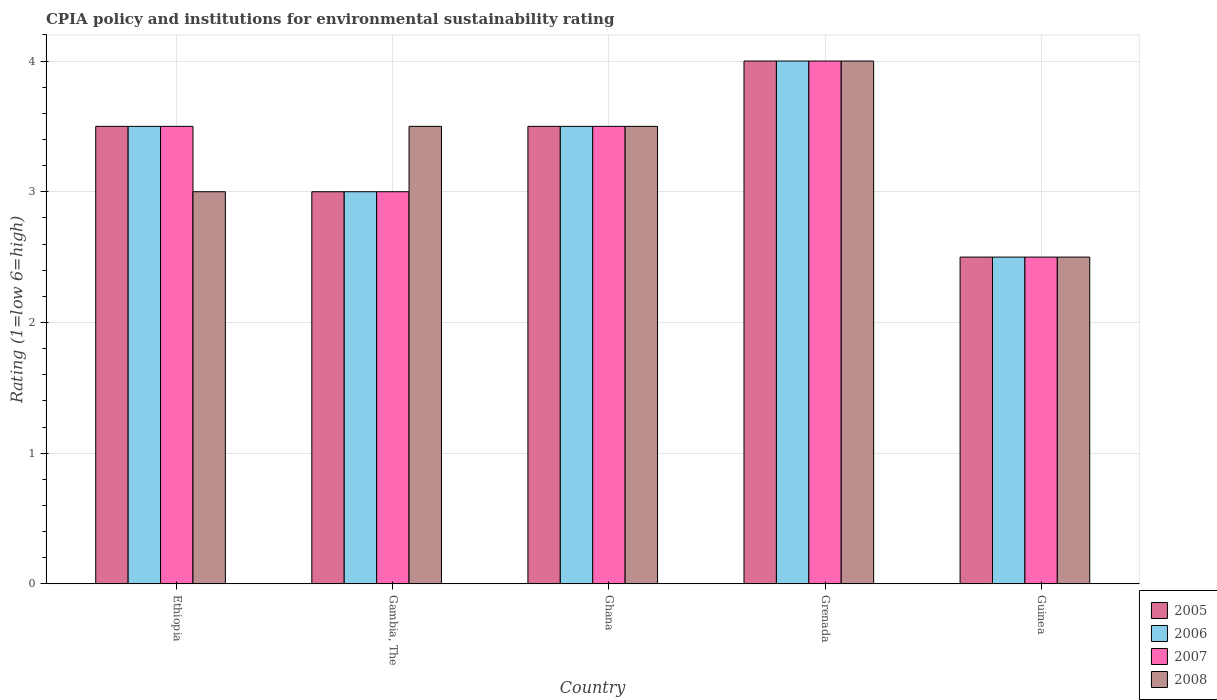How many groups of bars are there?
Ensure brevity in your answer.  5. What is the label of the 1st group of bars from the left?
Offer a terse response. Ethiopia. In how many cases, is the number of bars for a given country not equal to the number of legend labels?
Your answer should be compact. 0. What is the CPIA rating in 2007 in Guinea?
Provide a succinct answer. 2.5. Across all countries, what is the maximum CPIA rating in 2007?
Offer a terse response. 4. Across all countries, what is the minimum CPIA rating in 2006?
Offer a very short reply. 2.5. In which country was the CPIA rating in 2006 maximum?
Ensure brevity in your answer.  Grenada. In which country was the CPIA rating in 2006 minimum?
Provide a succinct answer. Guinea. What is the difference between the CPIA rating in 2008 in Ghana and that in Guinea?
Keep it short and to the point. 1. What is the average CPIA rating in 2005 per country?
Keep it short and to the point. 3.3. What is the difference between the CPIA rating of/in 2008 and CPIA rating of/in 2005 in Ghana?
Provide a succinct answer. 0. In how many countries, is the CPIA rating in 2005 greater than 1.6?
Offer a terse response. 5. Is the CPIA rating in 2007 in Ethiopia less than that in Grenada?
Provide a short and direct response. Yes. Is the sum of the CPIA rating in 2006 in Gambia, The and Guinea greater than the maximum CPIA rating in 2007 across all countries?
Offer a terse response. Yes. Is it the case that in every country, the sum of the CPIA rating in 2007 and CPIA rating in 2005 is greater than the sum of CPIA rating in 2008 and CPIA rating in 2006?
Offer a terse response. No. Are all the bars in the graph horizontal?
Your response must be concise. No. Does the graph contain any zero values?
Provide a succinct answer. No. Does the graph contain grids?
Offer a terse response. Yes. How many legend labels are there?
Ensure brevity in your answer.  4. What is the title of the graph?
Your answer should be compact. CPIA policy and institutions for environmental sustainability rating. Does "2005" appear as one of the legend labels in the graph?
Provide a short and direct response. Yes. What is the label or title of the X-axis?
Make the answer very short. Country. What is the Rating (1=low 6=high) of 2006 in Ethiopia?
Your answer should be compact. 3.5. What is the Rating (1=low 6=high) of 2005 in Gambia, The?
Offer a very short reply. 3. What is the Rating (1=low 6=high) of 2007 in Gambia, The?
Offer a very short reply. 3. What is the Rating (1=low 6=high) in 2005 in Guinea?
Provide a short and direct response. 2.5. What is the Rating (1=low 6=high) in 2006 in Guinea?
Give a very brief answer. 2.5. What is the Rating (1=low 6=high) of 2007 in Guinea?
Ensure brevity in your answer.  2.5. Across all countries, what is the maximum Rating (1=low 6=high) in 2005?
Ensure brevity in your answer.  4. Across all countries, what is the minimum Rating (1=low 6=high) in 2005?
Provide a short and direct response. 2.5. Across all countries, what is the minimum Rating (1=low 6=high) in 2007?
Provide a short and direct response. 2.5. Across all countries, what is the minimum Rating (1=low 6=high) of 2008?
Your answer should be compact. 2.5. What is the total Rating (1=low 6=high) in 2007 in the graph?
Offer a very short reply. 16.5. What is the total Rating (1=low 6=high) in 2008 in the graph?
Your answer should be compact. 16.5. What is the difference between the Rating (1=low 6=high) of 2005 in Ethiopia and that in Gambia, The?
Ensure brevity in your answer.  0.5. What is the difference between the Rating (1=low 6=high) of 2007 in Ethiopia and that in Gambia, The?
Provide a short and direct response. 0.5. What is the difference between the Rating (1=low 6=high) of 2008 in Ethiopia and that in Gambia, The?
Offer a very short reply. -0.5. What is the difference between the Rating (1=low 6=high) of 2007 in Ethiopia and that in Ghana?
Provide a succinct answer. 0. What is the difference between the Rating (1=low 6=high) in 2005 in Ethiopia and that in Grenada?
Your answer should be very brief. -0.5. What is the difference between the Rating (1=low 6=high) of 2006 in Ethiopia and that in Grenada?
Your answer should be very brief. -0.5. What is the difference between the Rating (1=low 6=high) of 2007 in Ethiopia and that in Grenada?
Offer a very short reply. -0.5. What is the difference between the Rating (1=low 6=high) of 2008 in Ethiopia and that in Grenada?
Your answer should be very brief. -1. What is the difference between the Rating (1=low 6=high) in 2005 in Ethiopia and that in Guinea?
Provide a succinct answer. 1. What is the difference between the Rating (1=low 6=high) of 2006 in Ethiopia and that in Guinea?
Make the answer very short. 1. What is the difference between the Rating (1=low 6=high) of 2007 in Ethiopia and that in Guinea?
Offer a very short reply. 1. What is the difference between the Rating (1=low 6=high) in 2005 in Gambia, The and that in Ghana?
Your answer should be compact. -0.5. What is the difference between the Rating (1=low 6=high) in 2007 in Gambia, The and that in Ghana?
Make the answer very short. -0.5. What is the difference between the Rating (1=low 6=high) in 2006 in Gambia, The and that in Grenada?
Offer a terse response. -1. What is the difference between the Rating (1=low 6=high) of 2008 in Gambia, The and that in Grenada?
Provide a succinct answer. -0.5. What is the difference between the Rating (1=low 6=high) in 2005 in Gambia, The and that in Guinea?
Provide a succinct answer. 0.5. What is the difference between the Rating (1=low 6=high) of 2008 in Gambia, The and that in Guinea?
Your response must be concise. 1. What is the difference between the Rating (1=low 6=high) of 2005 in Ghana and that in Grenada?
Make the answer very short. -0.5. What is the difference between the Rating (1=low 6=high) of 2006 in Grenada and that in Guinea?
Offer a terse response. 1.5. What is the difference between the Rating (1=low 6=high) of 2008 in Grenada and that in Guinea?
Your answer should be compact. 1.5. What is the difference between the Rating (1=low 6=high) in 2005 in Ethiopia and the Rating (1=low 6=high) in 2007 in Gambia, The?
Provide a short and direct response. 0.5. What is the difference between the Rating (1=low 6=high) in 2005 in Ethiopia and the Rating (1=low 6=high) in 2008 in Gambia, The?
Offer a very short reply. 0. What is the difference between the Rating (1=low 6=high) in 2006 in Ethiopia and the Rating (1=low 6=high) in 2008 in Gambia, The?
Make the answer very short. 0. What is the difference between the Rating (1=low 6=high) of 2007 in Ethiopia and the Rating (1=low 6=high) of 2008 in Gambia, The?
Offer a very short reply. 0. What is the difference between the Rating (1=low 6=high) in 2005 in Ethiopia and the Rating (1=low 6=high) in 2006 in Ghana?
Make the answer very short. 0. What is the difference between the Rating (1=low 6=high) of 2006 in Ethiopia and the Rating (1=low 6=high) of 2007 in Ghana?
Your response must be concise. 0. What is the difference between the Rating (1=low 6=high) in 2007 in Ethiopia and the Rating (1=low 6=high) in 2008 in Ghana?
Keep it short and to the point. 0. What is the difference between the Rating (1=low 6=high) in 2005 in Ethiopia and the Rating (1=low 6=high) in 2006 in Grenada?
Ensure brevity in your answer.  -0.5. What is the difference between the Rating (1=low 6=high) of 2005 in Ethiopia and the Rating (1=low 6=high) of 2008 in Grenada?
Ensure brevity in your answer.  -0.5. What is the difference between the Rating (1=low 6=high) of 2006 in Ethiopia and the Rating (1=low 6=high) of 2007 in Grenada?
Your answer should be compact. -0.5. What is the difference between the Rating (1=low 6=high) of 2006 in Ethiopia and the Rating (1=low 6=high) of 2008 in Grenada?
Make the answer very short. -0.5. What is the difference between the Rating (1=low 6=high) of 2007 in Ethiopia and the Rating (1=low 6=high) of 2008 in Grenada?
Keep it short and to the point. -0.5. What is the difference between the Rating (1=low 6=high) of 2005 in Ethiopia and the Rating (1=low 6=high) of 2007 in Guinea?
Offer a very short reply. 1. What is the difference between the Rating (1=low 6=high) of 2006 in Ethiopia and the Rating (1=low 6=high) of 2007 in Guinea?
Your response must be concise. 1. What is the difference between the Rating (1=low 6=high) of 2006 in Ethiopia and the Rating (1=low 6=high) of 2008 in Guinea?
Make the answer very short. 1. What is the difference between the Rating (1=low 6=high) in 2007 in Ethiopia and the Rating (1=low 6=high) in 2008 in Guinea?
Your answer should be very brief. 1. What is the difference between the Rating (1=low 6=high) in 2005 in Gambia, The and the Rating (1=low 6=high) in 2006 in Ghana?
Offer a terse response. -0.5. What is the difference between the Rating (1=low 6=high) of 2005 in Gambia, The and the Rating (1=low 6=high) of 2007 in Ghana?
Keep it short and to the point. -0.5. What is the difference between the Rating (1=low 6=high) of 2006 in Gambia, The and the Rating (1=low 6=high) of 2007 in Ghana?
Provide a succinct answer. -0.5. What is the difference between the Rating (1=low 6=high) of 2006 in Gambia, The and the Rating (1=low 6=high) of 2008 in Ghana?
Offer a terse response. -0.5. What is the difference between the Rating (1=low 6=high) of 2007 in Gambia, The and the Rating (1=low 6=high) of 2008 in Ghana?
Keep it short and to the point. -0.5. What is the difference between the Rating (1=low 6=high) in 2005 in Gambia, The and the Rating (1=low 6=high) in 2008 in Grenada?
Your answer should be compact. -1. What is the difference between the Rating (1=low 6=high) in 2006 in Gambia, The and the Rating (1=low 6=high) in 2007 in Grenada?
Your answer should be very brief. -1. What is the difference between the Rating (1=low 6=high) in 2007 in Gambia, The and the Rating (1=low 6=high) in 2008 in Grenada?
Your answer should be compact. -1. What is the difference between the Rating (1=low 6=high) in 2005 in Gambia, The and the Rating (1=low 6=high) in 2006 in Guinea?
Ensure brevity in your answer.  0.5. What is the difference between the Rating (1=low 6=high) of 2005 in Gambia, The and the Rating (1=low 6=high) of 2007 in Guinea?
Make the answer very short. 0.5. What is the difference between the Rating (1=low 6=high) in 2005 in Gambia, The and the Rating (1=low 6=high) in 2008 in Guinea?
Your response must be concise. 0.5. What is the difference between the Rating (1=low 6=high) in 2005 in Ghana and the Rating (1=low 6=high) in 2006 in Grenada?
Give a very brief answer. -0.5. What is the difference between the Rating (1=low 6=high) of 2005 in Ghana and the Rating (1=low 6=high) of 2008 in Grenada?
Your answer should be very brief. -0.5. What is the difference between the Rating (1=low 6=high) in 2006 in Ghana and the Rating (1=low 6=high) in 2007 in Grenada?
Keep it short and to the point. -0.5. What is the difference between the Rating (1=low 6=high) of 2007 in Ghana and the Rating (1=low 6=high) of 2008 in Grenada?
Keep it short and to the point. -0.5. What is the difference between the Rating (1=low 6=high) in 2005 in Ghana and the Rating (1=low 6=high) in 2006 in Guinea?
Your response must be concise. 1. What is the difference between the Rating (1=low 6=high) of 2005 in Ghana and the Rating (1=low 6=high) of 2007 in Guinea?
Your answer should be very brief. 1. What is the difference between the Rating (1=low 6=high) in 2006 in Ghana and the Rating (1=low 6=high) in 2007 in Guinea?
Keep it short and to the point. 1. What is the difference between the Rating (1=low 6=high) of 2007 in Ghana and the Rating (1=low 6=high) of 2008 in Guinea?
Offer a very short reply. 1. What is the difference between the Rating (1=low 6=high) in 2005 in Grenada and the Rating (1=low 6=high) in 2007 in Guinea?
Your answer should be very brief. 1.5. What is the difference between the Rating (1=low 6=high) of 2006 in Grenada and the Rating (1=low 6=high) of 2008 in Guinea?
Offer a very short reply. 1.5. What is the average Rating (1=low 6=high) in 2005 per country?
Your answer should be very brief. 3.3. What is the average Rating (1=low 6=high) of 2006 per country?
Your answer should be compact. 3.3. What is the average Rating (1=low 6=high) in 2008 per country?
Provide a short and direct response. 3.3. What is the difference between the Rating (1=low 6=high) of 2005 and Rating (1=low 6=high) of 2006 in Ethiopia?
Keep it short and to the point. 0. What is the difference between the Rating (1=low 6=high) in 2005 and Rating (1=low 6=high) in 2008 in Ethiopia?
Provide a succinct answer. 0.5. What is the difference between the Rating (1=low 6=high) in 2006 and Rating (1=low 6=high) in 2007 in Ethiopia?
Offer a terse response. 0. What is the difference between the Rating (1=low 6=high) of 2007 and Rating (1=low 6=high) of 2008 in Ethiopia?
Your answer should be very brief. 0.5. What is the difference between the Rating (1=low 6=high) in 2005 and Rating (1=low 6=high) in 2007 in Gambia, The?
Provide a succinct answer. 0. What is the difference between the Rating (1=low 6=high) in 2006 and Rating (1=low 6=high) in 2007 in Gambia, The?
Ensure brevity in your answer.  0. What is the difference between the Rating (1=low 6=high) of 2006 and Rating (1=low 6=high) of 2008 in Gambia, The?
Your response must be concise. -0.5. What is the difference between the Rating (1=low 6=high) of 2007 and Rating (1=low 6=high) of 2008 in Gambia, The?
Keep it short and to the point. -0.5. What is the difference between the Rating (1=low 6=high) in 2005 and Rating (1=low 6=high) in 2006 in Ghana?
Your answer should be compact. 0. What is the difference between the Rating (1=low 6=high) in 2005 and Rating (1=low 6=high) in 2008 in Ghana?
Offer a terse response. 0. What is the difference between the Rating (1=low 6=high) in 2006 and Rating (1=low 6=high) in 2007 in Ghana?
Make the answer very short. 0. What is the difference between the Rating (1=low 6=high) in 2007 and Rating (1=low 6=high) in 2008 in Ghana?
Your answer should be compact. 0. What is the difference between the Rating (1=low 6=high) of 2005 and Rating (1=low 6=high) of 2006 in Grenada?
Provide a succinct answer. 0. What is the difference between the Rating (1=low 6=high) of 2005 and Rating (1=low 6=high) of 2007 in Grenada?
Your answer should be compact. 0. What is the difference between the Rating (1=low 6=high) in 2005 and Rating (1=low 6=high) in 2008 in Grenada?
Make the answer very short. 0. What is the difference between the Rating (1=low 6=high) of 2006 and Rating (1=low 6=high) of 2007 in Grenada?
Offer a very short reply. 0. What is the difference between the Rating (1=low 6=high) in 2007 and Rating (1=low 6=high) in 2008 in Grenada?
Your answer should be very brief. 0. What is the difference between the Rating (1=low 6=high) in 2005 and Rating (1=low 6=high) in 2007 in Guinea?
Keep it short and to the point. 0. What is the difference between the Rating (1=low 6=high) of 2006 and Rating (1=low 6=high) of 2007 in Guinea?
Offer a very short reply. 0. What is the difference between the Rating (1=low 6=high) of 2007 and Rating (1=low 6=high) of 2008 in Guinea?
Give a very brief answer. 0. What is the ratio of the Rating (1=low 6=high) of 2006 in Ethiopia to that in Gambia, The?
Keep it short and to the point. 1.17. What is the ratio of the Rating (1=low 6=high) in 2008 in Ethiopia to that in Gambia, The?
Offer a terse response. 0.86. What is the ratio of the Rating (1=low 6=high) of 2005 in Ethiopia to that in Ghana?
Ensure brevity in your answer.  1. What is the ratio of the Rating (1=low 6=high) in 2006 in Ethiopia to that in Ghana?
Offer a very short reply. 1. What is the ratio of the Rating (1=low 6=high) of 2007 in Ethiopia to that in Ghana?
Ensure brevity in your answer.  1. What is the ratio of the Rating (1=low 6=high) in 2008 in Ethiopia to that in Ghana?
Make the answer very short. 0.86. What is the ratio of the Rating (1=low 6=high) of 2005 in Ethiopia to that in Grenada?
Provide a succinct answer. 0.88. What is the ratio of the Rating (1=low 6=high) of 2006 in Ethiopia to that in Grenada?
Provide a succinct answer. 0.88. What is the ratio of the Rating (1=low 6=high) of 2006 in Ethiopia to that in Guinea?
Provide a succinct answer. 1.4. What is the ratio of the Rating (1=low 6=high) of 2007 in Ethiopia to that in Guinea?
Your answer should be very brief. 1.4. What is the ratio of the Rating (1=low 6=high) in 2008 in Ethiopia to that in Guinea?
Make the answer very short. 1.2. What is the ratio of the Rating (1=low 6=high) of 2006 in Gambia, The to that in Ghana?
Provide a succinct answer. 0.86. What is the ratio of the Rating (1=low 6=high) in 2008 in Gambia, The to that in Ghana?
Provide a short and direct response. 1. What is the ratio of the Rating (1=low 6=high) of 2005 in Gambia, The to that in Grenada?
Your answer should be compact. 0.75. What is the ratio of the Rating (1=low 6=high) of 2006 in Gambia, The to that in Grenada?
Your answer should be compact. 0.75. What is the ratio of the Rating (1=low 6=high) in 2007 in Gambia, The to that in Grenada?
Your response must be concise. 0.75. What is the ratio of the Rating (1=low 6=high) in 2008 in Gambia, The to that in Grenada?
Offer a very short reply. 0.88. What is the ratio of the Rating (1=low 6=high) of 2007 in Gambia, The to that in Guinea?
Ensure brevity in your answer.  1.2. What is the ratio of the Rating (1=low 6=high) in 2008 in Gambia, The to that in Guinea?
Provide a short and direct response. 1.4. What is the ratio of the Rating (1=low 6=high) in 2007 in Ghana to that in Grenada?
Give a very brief answer. 0.88. What is the ratio of the Rating (1=low 6=high) in 2008 in Ghana to that in Grenada?
Your answer should be compact. 0.88. What is the ratio of the Rating (1=low 6=high) in 2006 in Grenada to that in Guinea?
Provide a succinct answer. 1.6. What is the ratio of the Rating (1=low 6=high) of 2007 in Grenada to that in Guinea?
Keep it short and to the point. 1.6. What is the difference between the highest and the second highest Rating (1=low 6=high) in 2007?
Ensure brevity in your answer.  0.5. What is the difference between the highest and the lowest Rating (1=low 6=high) in 2005?
Provide a short and direct response. 1.5. What is the difference between the highest and the lowest Rating (1=low 6=high) in 2007?
Your response must be concise. 1.5. What is the difference between the highest and the lowest Rating (1=low 6=high) in 2008?
Offer a very short reply. 1.5. 